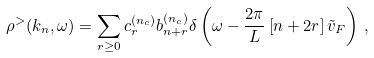<formula> <loc_0><loc_0><loc_500><loc_500>\rho ^ { > } ( k _ { n } , \omega ) = \sum _ { r \geq 0 } c _ { r } ^ { ( n _ { c } ) } b _ { n + r } ^ { ( n _ { c } ) } \delta \left ( \omega - \frac { 2 \pi } { L } \left [ n + 2 r \right ] \tilde { v } _ { F } \right ) \, ,</formula> 